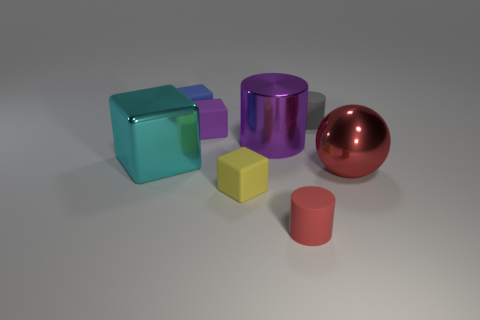Subtract all blue blocks. How many blocks are left? 3 Add 1 blue rubber cubes. How many objects exist? 9 Subtract all yellow blocks. How many blocks are left? 3 Subtract all cylinders. How many objects are left? 5 Subtract 2 cylinders. How many cylinders are left? 1 Subtract 0 red cubes. How many objects are left? 8 Subtract all cyan cylinders. Subtract all red blocks. How many cylinders are left? 3 Subtract all small gray metallic blocks. Subtract all tiny red things. How many objects are left? 7 Add 6 purple cubes. How many purple cubes are left? 7 Add 6 tiny yellow rubber objects. How many tiny yellow rubber objects exist? 7 